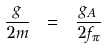<formula> <loc_0><loc_0><loc_500><loc_500>\frac { g } { 2 m } \ = \ \frac { g _ { A } } { 2 f _ { \pi } }</formula> 